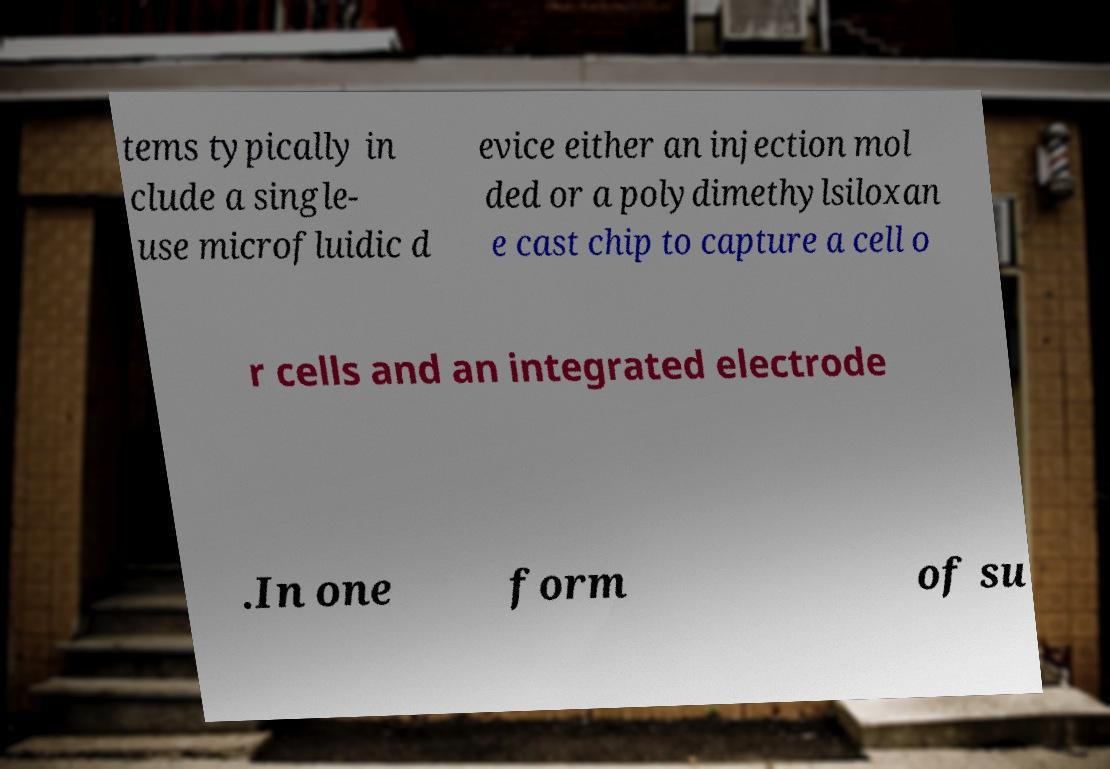Can you accurately transcribe the text from the provided image for me? tems typically in clude a single- use microfluidic d evice either an injection mol ded or a polydimethylsiloxan e cast chip to capture a cell o r cells and an integrated electrode .In one form of su 